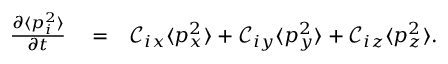Convert formula to latex. <formula><loc_0><loc_0><loc_500><loc_500>\begin{array} { r l r } { \frac { \partial \langle p _ { i } ^ { 2 } \rangle } { \partial t } } & = } & { \mathcal { C } _ { i x } \langle p _ { x } ^ { 2 } \rangle + \mathcal { C } _ { i y } \langle p _ { y } ^ { 2 } \rangle + \mathcal { C } _ { i z } \langle p _ { z } ^ { 2 } \rangle . } \end{array}</formula> 